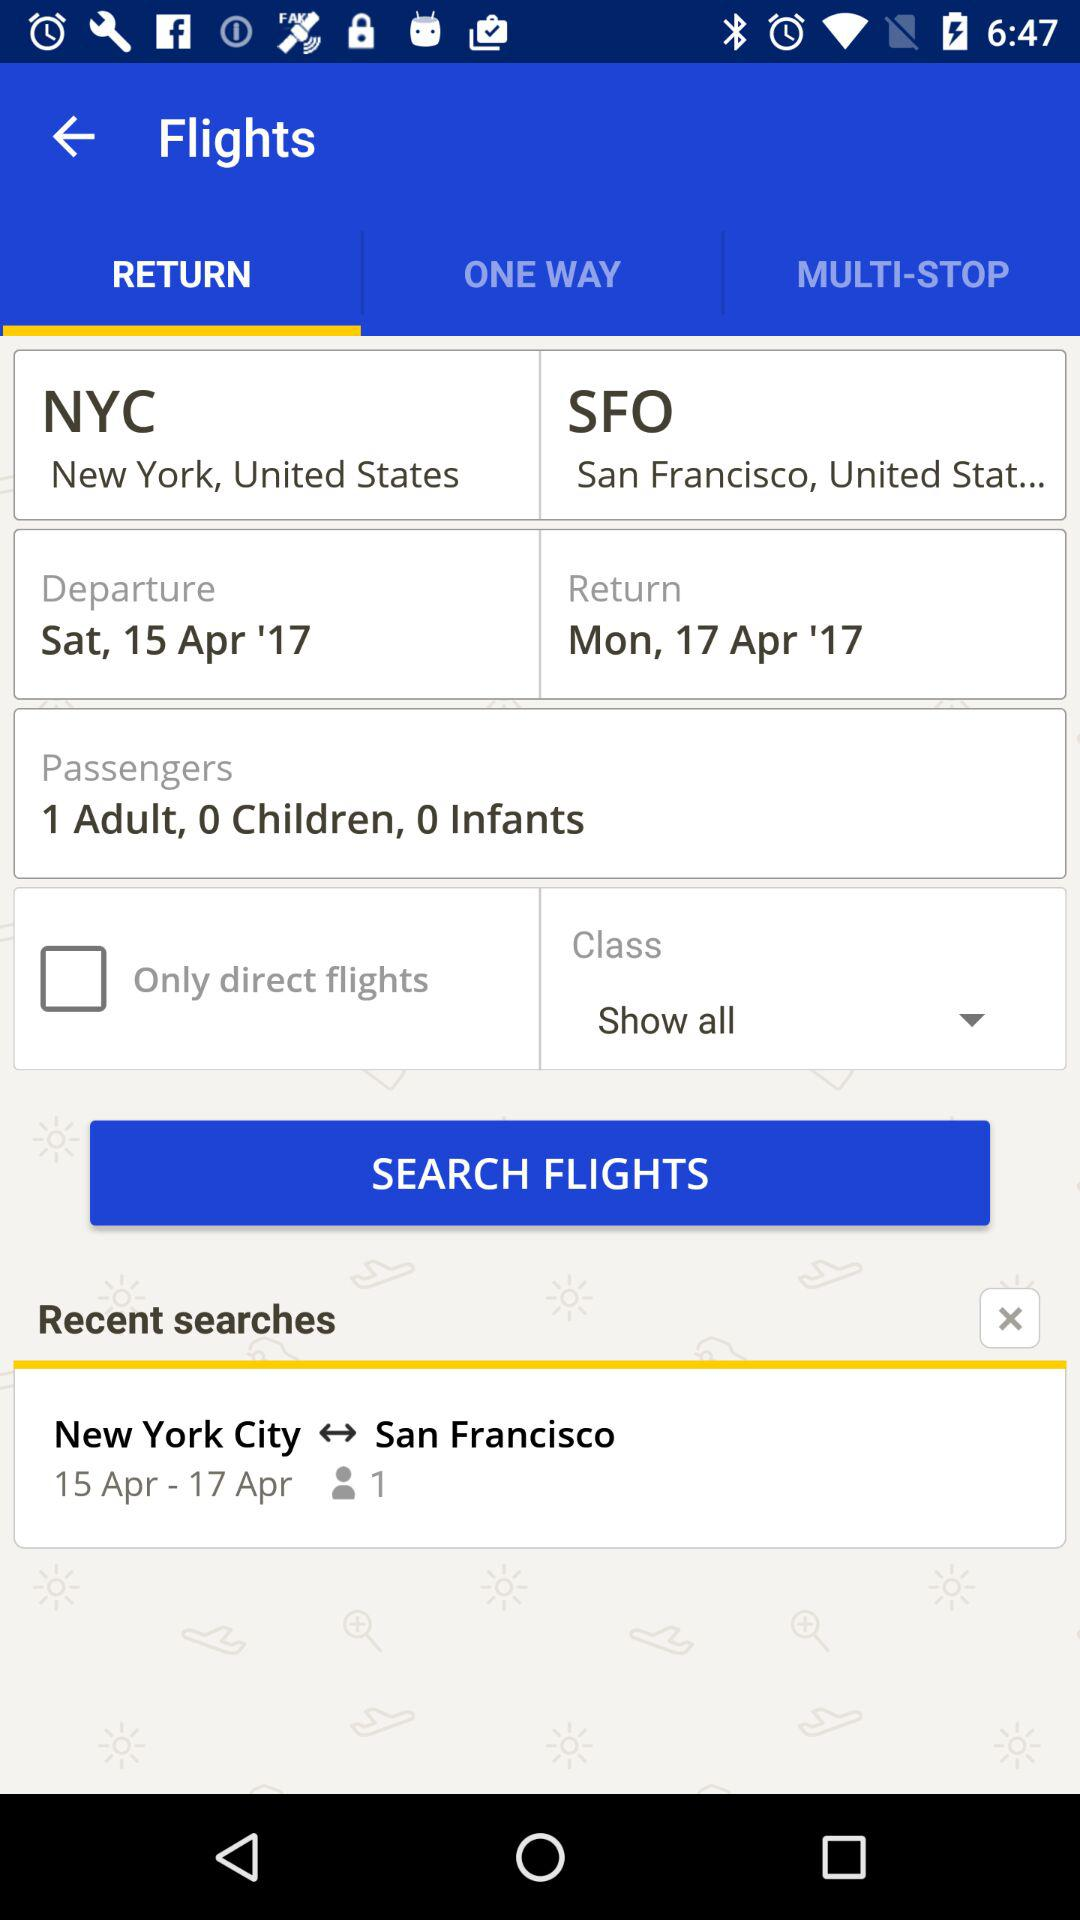What is the passengers name?
When the provided information is insufficient, respond with <no answer>. <no answer> 